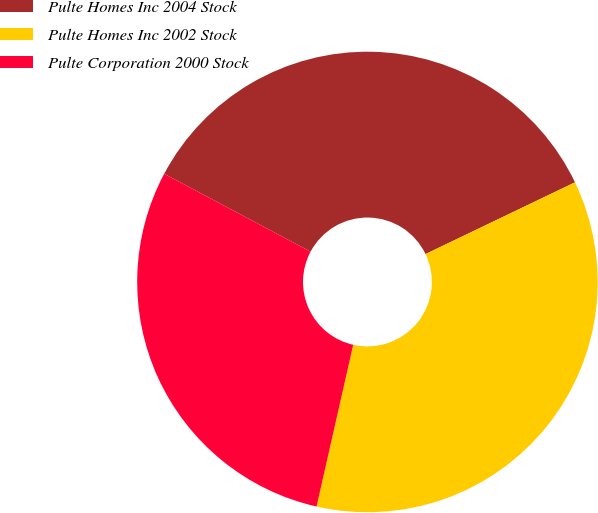<chart> <loc_0><loc_0><loc_500><loc_500><pie_chart><fcel>Pulte Homes Inc 2004 Stock<fcel>Pulte Homes Inc 2002 Stock<fcel>Pulte Corporation 2000 Stock<nl><fcel>35.09%<fcel>35.67%<fcel>29.24%<nl></chart> 